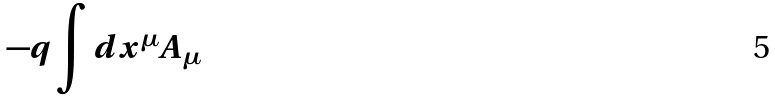<formula> <loc_0><loc_0><loc_500><loc_500>- q \int d x ^ { \mu } A _ { \mu }</formula> 